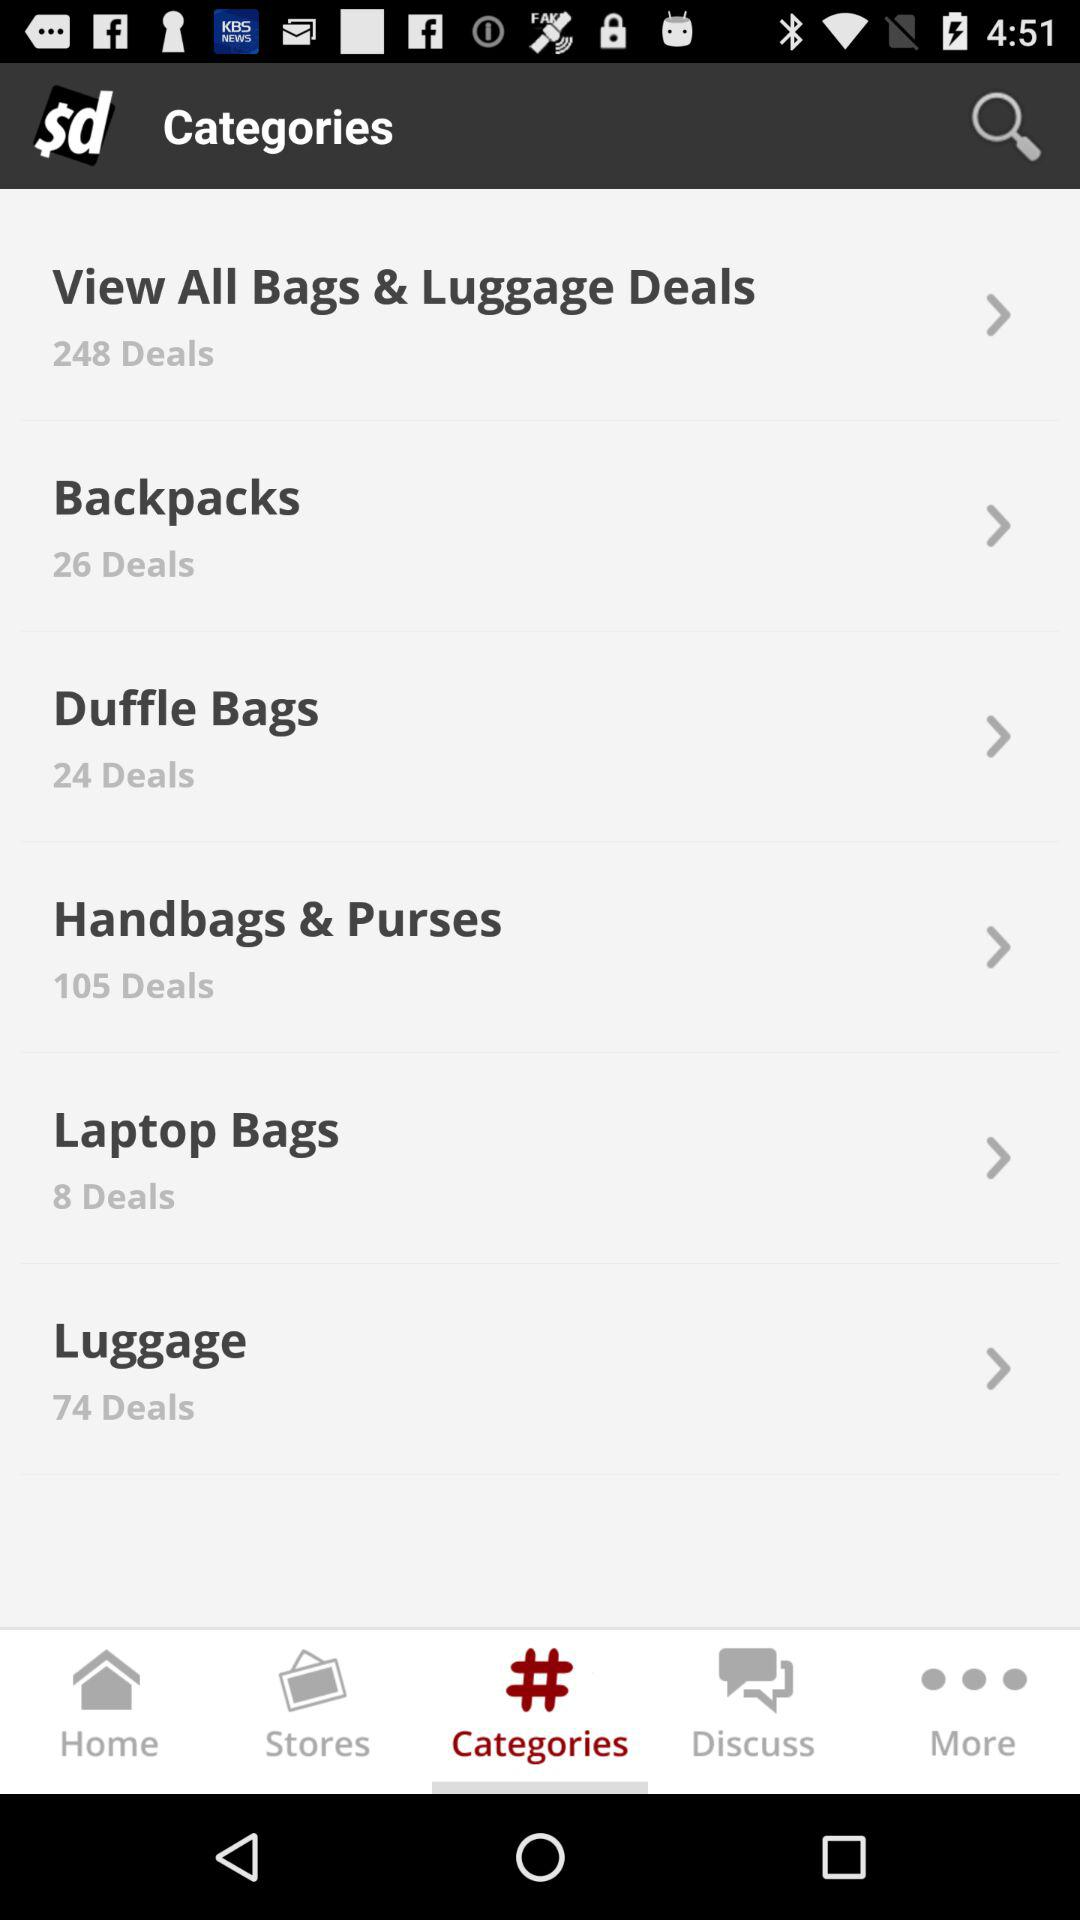How many deals are for handbags and purses? There are 105 deals for handbags and purses. 